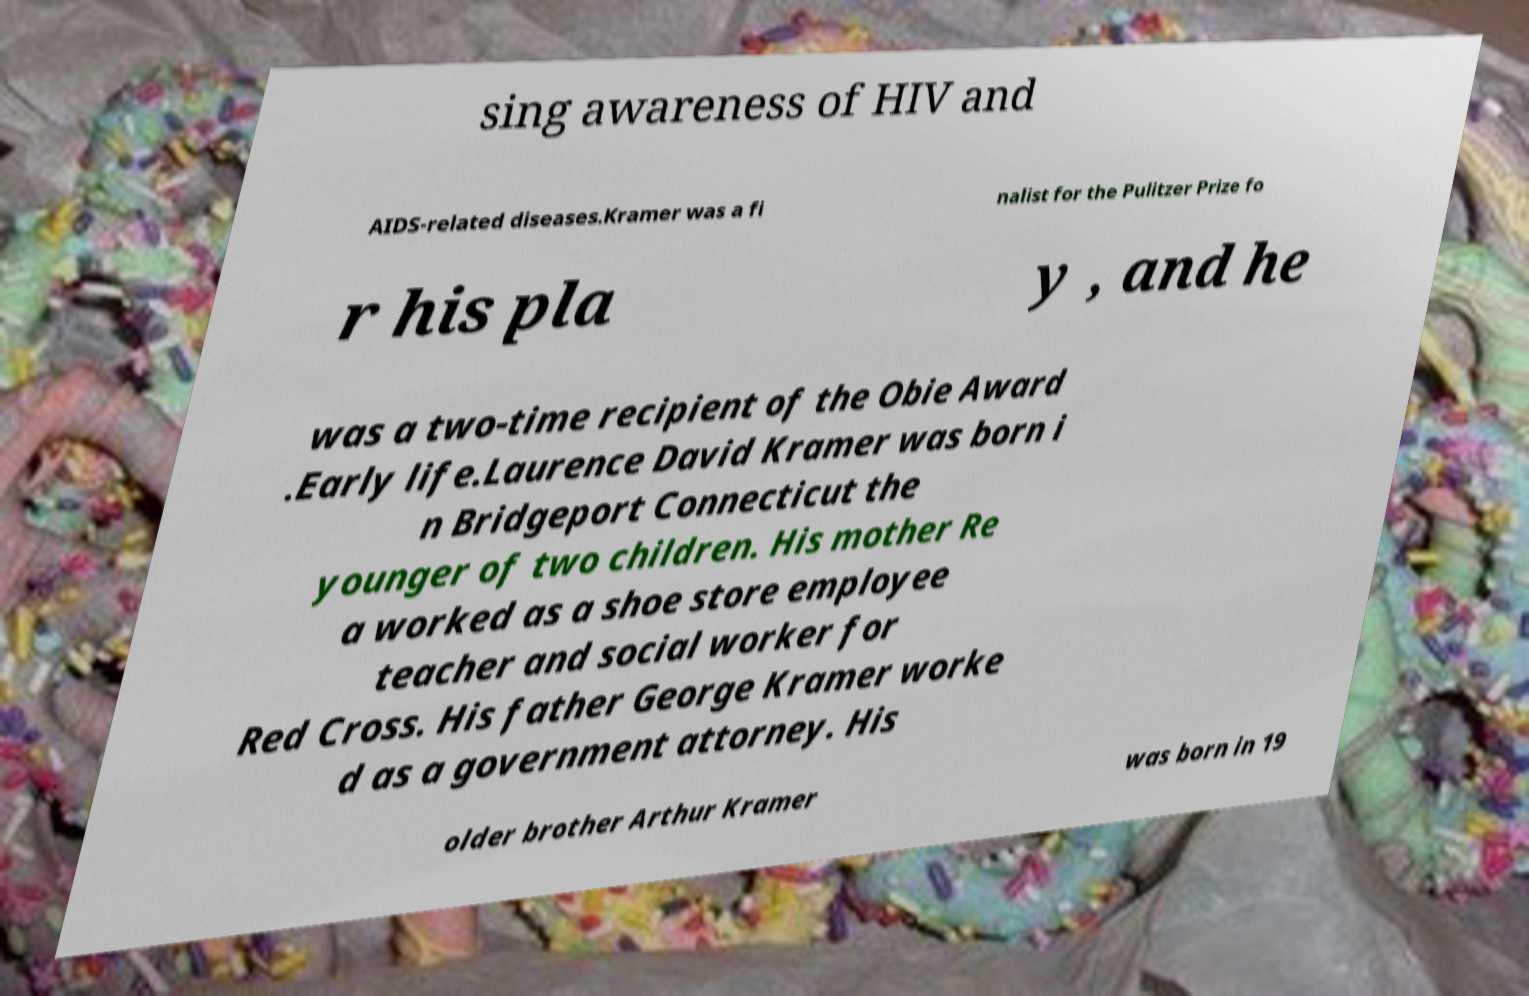What messages or text are displayed in this image? I need them in a readable, typed format. sing awareness of HIV and AIDS-related diseases.Kramer was a fi nalist for the Pulitzer Prize fo r his pla y , and he was a two-time recipient of the Obie Award .Early life.Laurence David Kramer was born i n Bridgeport Connecticut the younger of two children. His mother Re a worked as a shoe store employee teacher and social worker for Red Cross. His father George Kramer worke d as a government attorney. His older brother Arthur Kramer was born in 19 